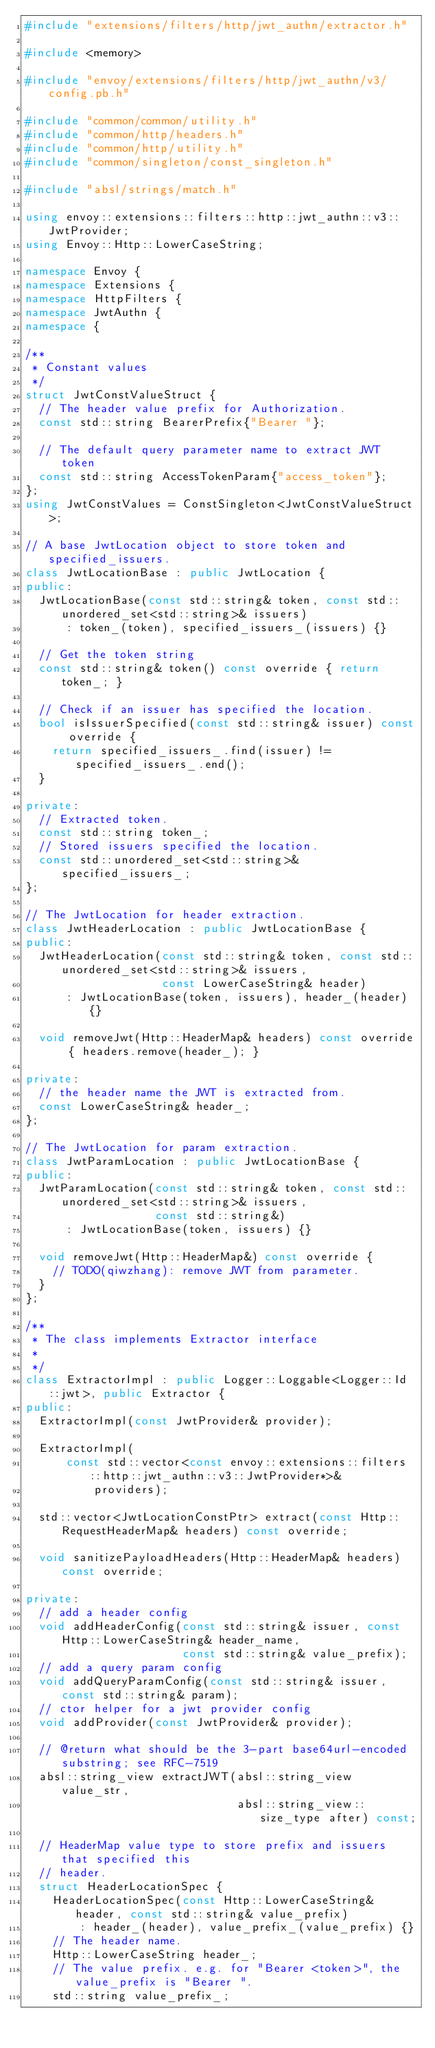<code> <loc_0><loc_0><loc_500><loc_500><_C++_>#include "extensions/filters/http/jwt_authn/extractor.h"

#include <memory>

#include "envoy/extensions/filters/http/jwt_authn/v3/config.pb.h"

#include "common/common/utility.h"
#include "common/http/headers.h"
#include "common/http/utility.h"
#include "common/singleton/const_singleton.h"

#include "absl/strings/match.h"

using envoy::extensions::filters::http::jwt_authn::v3::JwtProvider;
using Envoy::Http::LowerCaseString;

namespace Envoy {
namespace Extensions {
namespace HttpFilters {
namespace JwtAuthn {
namespace {

/**
 * Constant values
 */
struct JwtConstValueStruct {
  // The header value prefix for Authorization.
  const std::string BearerPrefix{"Bearer "};

  // The default query parameter name to extract JWT token
  const std::string AccessTokenParam{"access_token"};
};
using JwtConstValues = ConstSingleton<JwtConstValueStruct>;

// A base JwtLocation object to store token and specified_issuers.
class JwtLocationBase : public JwtLocation {
public:
  JwtLocationBase(const std::string& token, const std::unordered_set<std::string>& issuers)
      : token_(token), specified_issuers_(issuers) {}

  // Get the token string
  const std::string& token() const override { return token_; }

  // Check if an issuer has specified the location.
  bool isIssuerSpecified(const std::string& issuer) const override {
    return specified_issuers_.find(issuer) != specified_issuers_.end();
  }

private:
  // Extracted token.
  const std::string token_;
  // Stored issuers specified the location.
  const std::unordered_set<std::string>& specified_issuers_;
};

// The JwtLocation for header extraction.
class JwtHeaderLocation : public JwtLocationBase {
public:
  JwtHeaderLocation(const std::string& token, const std::unordered_set<std::string>& issuers,
                    const LowerCaseString& header)
      : JwtLocationBase(token, issuers), header_(header) {}

  void removeJwt(Http::HeaderMap& headers) const override { headers.remove(header_); }

private:
  // the header name the JWT is extracted from.
  const LowerCaseString& header_;
};

// The JwtLocation for param extraction.
class JwtParamLocation : public JwtLocationBase {
public:
  JwtParamLocation(const std::string& token, const std::unordered_set<std::string>& issuers,
                   const std::string&)
      : JwtLocationBase(token, issuers) {}

  void removeJwt(Http::HeaderMap&) const override {
    // TODO(qiwzhang): remove JWT from parameter.
  }
};

/**
 * The class implements Extractor interface
 *
 */
class ExtractorImpl : public Logger::Loggable<Logger::Id::jwt>, public Extractor {
public:
  ExtractorImpl(const JwtProvider& provider);

  ExtractorImpl(
      const std::vector<const envoy::extensions::filters::http::jwt_authn::v3::JwtProvider*>&
          providers);

  std::vector<JwtLocationConstPtr> extract(const Http::RequestHeaderMap& headers) const override;

  void sanitizePayloadHeaders(Http::HeaderMap& headers) const override;

private:
  // add a header config
  void addHeaderConfig(const std::string& issuer, const Http::LowerCaseString& header_name,
                       const std::string& value_prefix);
  // add a query param config
  void addQueryParamConfig(const std::string& issuer, const std::string& param);
  // ctor helper for a jwt provider config
  void addProvider(const JwtProvider& provider);

  // @return what should be the 3-part base64url-encoded substring; see RFC-7519
  absl::string_view extractJWT(absl::string_view value_str,
                               absl::string_view::size_type after) const;

  // HeaderMap value type to store prefix and issuers that specified this
  // header.
  struct HeaderLocationSpec {
    HeaderLocationSpec(const Http::LowerCaseString& header, const std::string& value_prefix)
        : header_(header), value_prefix_(value_prefix) {}
    // The header name.
    Http::LowerCaseString header_;
    // The value prefix. e.g. for "Bearer <token>", the value_prefix is "Bearer ".
    std::string value_prefix_;</code> 